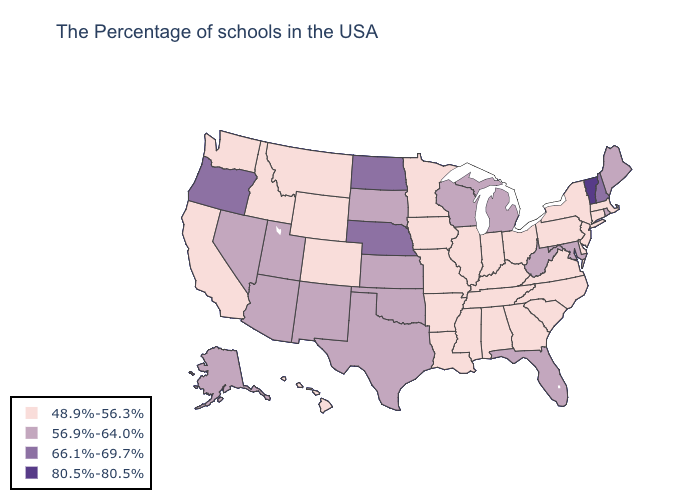Does the map have missing data?
Quick response, please. No. Does North Dakota have the highest value in the MidWest?
Concise answer only. Yes. Does South Carolina have the highest value in the USA?
Be succinct. No. Does Tennessee have the same value as Rhode Island?
Short answer required. No. What is the value of Georgia?
Write a very short answer. 48.9%-56.3%. Among the states that border Michigan , does Wisconsin have the highest value?
Give a very brief answer. Yes. Which states hav the highest value in the West?
Answer briefly. Oregon. What is the lowest value in the USA?
Quick response, please. 48.9%-56.3%. Does the map have missing data?
Concise answer only. No. Name the states that have a value in the range 66.1%-69.7%?
Give a very brief answer. New Hampshire, Nebraska, North Dakota, Oregon. What is the highest value in the West ?
Keep it brief. 66.1%-69.7%. Does Kansas have a lower value than Oregon?
Write a very short answer. Yes. Does Maine have a lower value than Kansas?
Concise answer only. No. What is the highest value in the USA?
Keep it brief. 80.5%-80.5%. What is the value of Idaho?
Concise answer only. 48.9%-56.3%. 